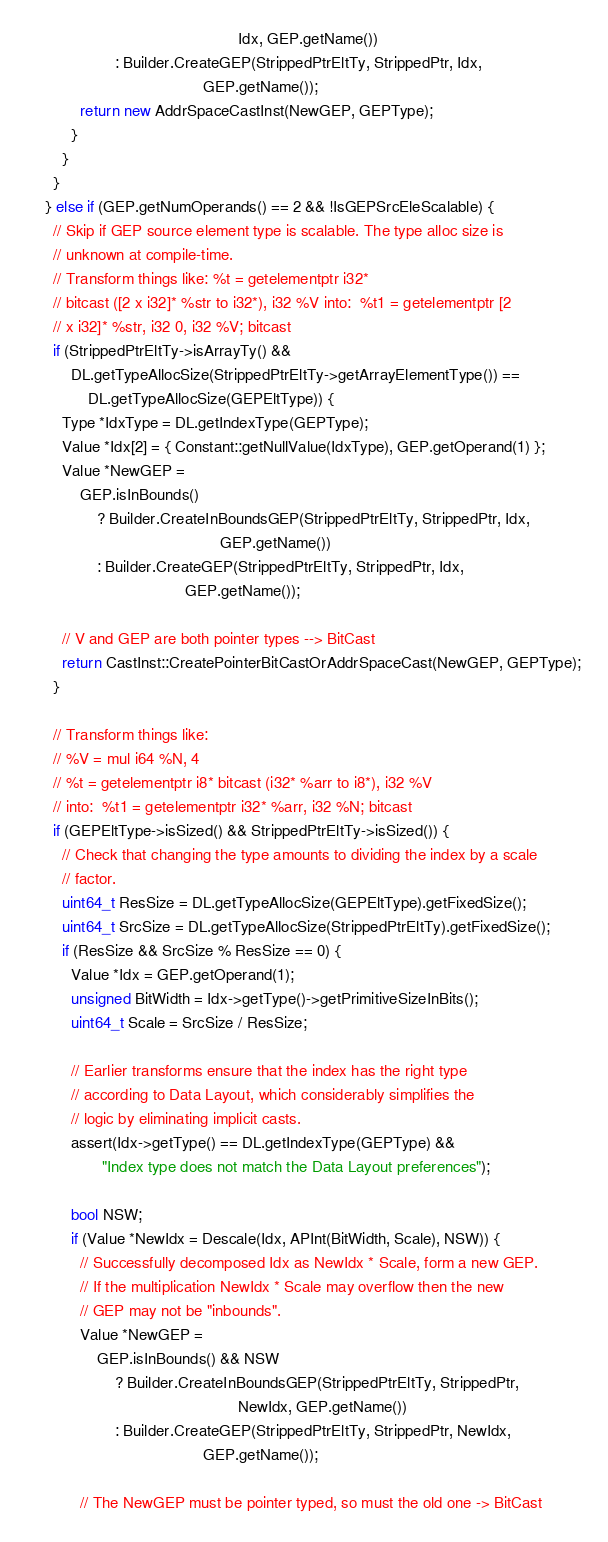<code> <loc_0><loc_0><loc_500><loc_500><_C++_>                                                Idx, GEP.getName())
                    : Builder.CreateGEP(StrippedPtrEltTy, StrippedPtr, Idx,
                                        GEP.getName());
            return new AddrSpaceCastInst(NewGEP, GEPType);
          }
        }
      }
    } else if (GEP.getNumOperands() == 2 && !IsGEPSrcEleScalable) {
      // Skip if GEP source element type is scalable. The type alloc size is
      // unknown at compile-time.
      // Transform things like: %t = getelementptr i32*
      // bitcast ([2 x i32]* %str to i32*), i32 %V into:  %t1 = getelementptr [2
      // x i32]* %str, i32 0, i32 %V; bitcast
      if (StrippedPtrEltTy->isArrayTy() &&
          DL.getTypeAllocSize(StrippedPtrEltTy->getArrayElementType()) ==
              DL.getTypeAllocSize(GEPEltType)) {
        Type *IdxType = DL.getIndexType(GEPType);
        Value *Idx[2] = { Constant::getNullValue(IdxType), GEP.getOperand(1) };
        Value *NewGEP =
            GEP.isInBounds()
                ? Builder.CreateInBoundsGEP(StrippedPtrEltTy, StrippedPtr, Idx,
                                            GEP.getName())
                : Builder.CreateGEP(StrippedPtrEltTy, StrippedPtr, Idx,
                                    GEP.getName());

        // V and GEP are both pointer types --> BitCast
        return CastInst::CreatePointerBitCastOrAddrSpaceCast(NewGEP, GEPType);
      }

      // Transform things like:
      // %V = mul i64 %N, 4
      // %t = getelementptr i8* bitcast (i32* %arr to i8*), i32 %V
      // into:  %t1 = getelementptr i32* %arr, i32 %N; bitcast
      if (GEPEltType->isSized() && StrippedPtrEltTy->isSized()) {
        // Check that changing the type amounts to dividing the index by a scale
        // factor.
        uint64_t ResSize = DL.getTypeAllocSize(GEPEltType).getFixedSize();
        uint64_t SrcSize = DL.getTypeAllocSize(StrippedPtrEltTy).getFixedSize();
        if (ResSize && SrcSize % ResSize == 0) {
          Value *Idx = GEP.getOperand(1);
          unsigned BitWidth = Idx->getType()->getPrimitiveSizeInBits();
          uint64_t Scale = SrcSize / ResSize;

          // Earlier transforms ensure that the index has the right type
          // according to Data Layout, which considerably simplifies the
          // logic by eliminating implicit casts.
          assert(Idx->getType() == DL.getIndexType(GEPType) &&
                 "Index type does not match the Data Layout preferences");

          bool NSW;
          if (Value *NewIdx = Descale(Idx, APInt(BitWidth, Scale), NSW)) {
            // Successfully decomposed Idx as NewIdx * Scale, form a new GEP.
            // If the multiplication NewIdx * Scale may overflow then the new
            // GEP may not be "inbounds".
            Value *NewGEP =
                GEP.isInBounds() && NSW
                    ? Builder.CreateInBoundsGEP(StrippedPtrEltTy, StrippedPtr,
                                                NewIdx, GEP.getName())
                    : Builder.CreateGEP(StrippedPtrEltTy, StrippedPtr, NewIdx,
                                        GEP.getName());

            // The NewGEP must be pointer typed, so must the old one -> BitCast</code> 